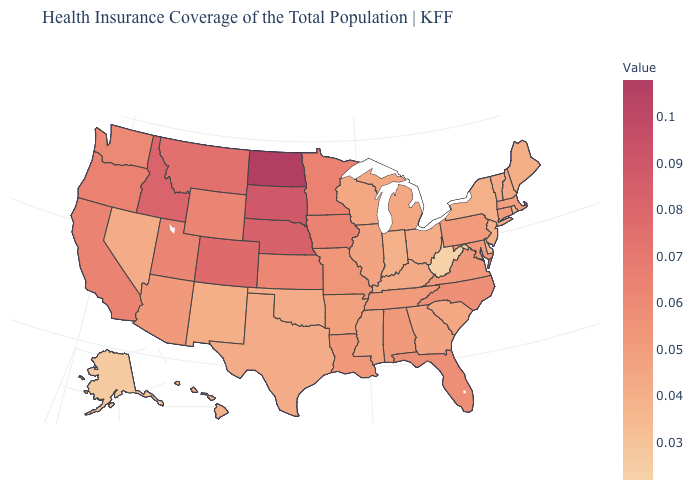Which states have the lowest value in the USA?
Be succinct. West Virginia. Is the legend a continuous bar?
Answer briefly. Yes. Among the states that border Missouri , does Iowa have the lowest value?
Be succinct. No. Among the states that border North Carolina , which have the highest value?
Short answer required. Virginia. Among the states that border Illinois , which have the lowest value?
Concise answer only. Indiana. 